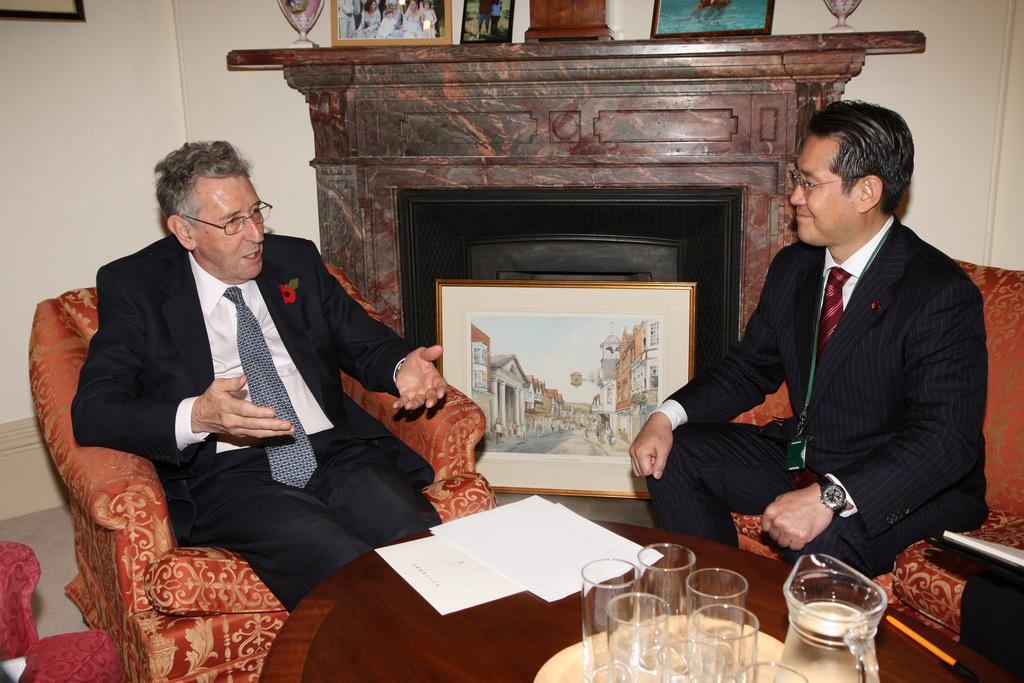Please provide a concise description of this image. In this image i can see there are two men who are sitting on a chair in front of a table. On the table i can see there are few glasses and other objects on it. 